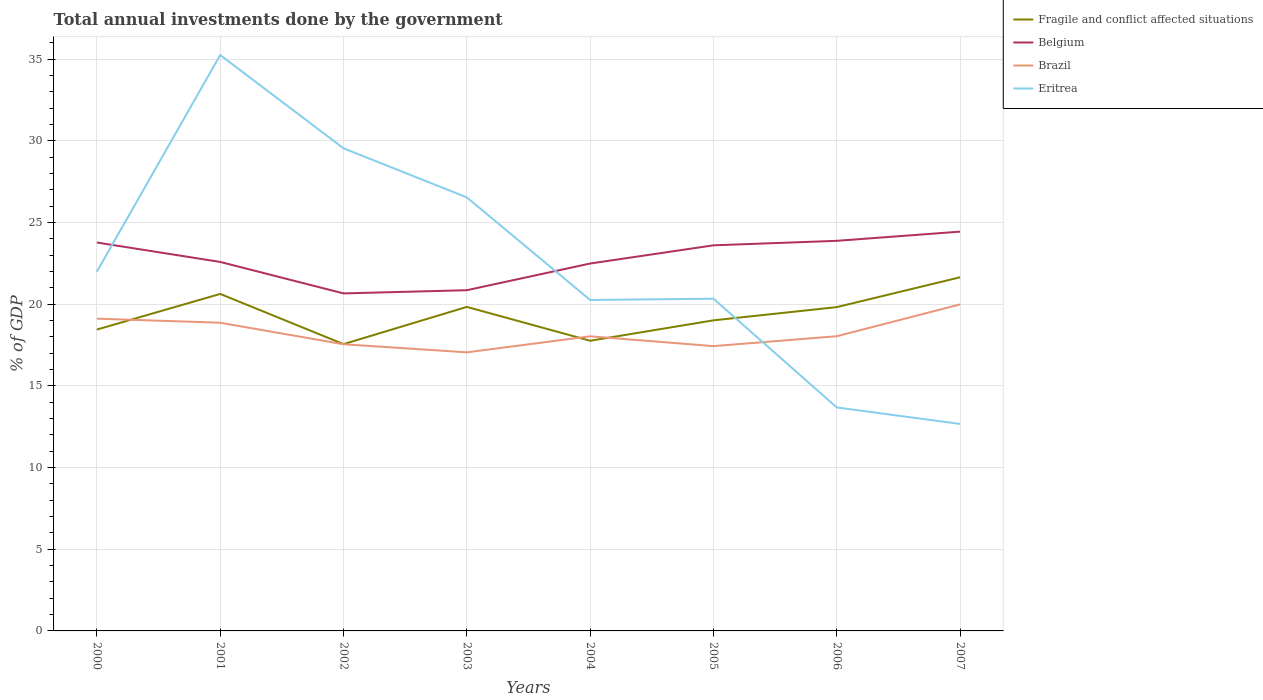Does the line corresponding to Fragile and conflict affected situations intersect with the line corresponding to Belgium?
Keep it short and to the point. No. Across all years, what is the maximum total annual investments done by the government in Fragile and conflict affected situations?
Keep it short and to the point. 17.56. In which year was the total annual investments done by the government in Fragile and conflict affected situations maximum?
Your answer should be very brief. 2002. What is the total total annual investments done by the government in Brazil in the graph?
Keep it short and to the point. -0.49. What is the difference between the highest and the second highest total annual investments done by the government in Belgium?
Offer a very short reply. 3.78. What is the difference between the highest and the lowest total annual investments done by the government in Belgium?
Give a very brief answer. 4. How many lines are there?
Your response must be concise. 4. How many years are there in the graph?
Give a very brief answer. 8. What is the difference between two consecutive major ticks on the Y-axis?
Your answer should be compact. 5. Does the graph contain any zero values?
Your answer should be compact. No. Does the graph contain grids?
Your answer should be compact. Yes. How are the legend labels stacked?
Your answer should be very brief. Vertical. What is the title of the graph?
Provide a succinct answer. Total annual investments done by the government. What is the label or title of the Y-axis?
Provide a succinct answer. % of GDP. What is the % of GDP in Fragile and conflict affected situations in 2000?
Your answer should be compact. 18.45. What is the % of GDP in Belgium in 2000?
Your answer should be very brief. 23.78. What is the % of GDP of Brazil in 2000?
Make the answer very short. 19.12. What is the % of GDP in Eritrea in 2000?
Your response must be concise. 22. What is the % of GDP of Fragile and conflict affected situations in 2001?
Offer a very short reply. 20.63. What is the % of GDP of Belgium in 2001?
Ensure brevity in your answer.  22.59. What is the % of GDP of Brazil in 2001?
Provide a short and direct response. 18.87. What is the % of GDP in Eritrea in 2001?
Offer a terse response. 35.26. What is the % of GDP of Fragile and conflict affected situations in 2002?
Make the answer very short. 17.56. What is the % of GDP of Belgium in 2002?
Give a very brief answer. 20.66. What is the % of GDP of Brazil in 2002?
Offer a terse response. 17.55. What is the % of GDP in Eritrea in 2002?
Provide a short and direct response. 29.55. What is the % of GDP of Fragile and conflict affected situations in 2003?
Your answer should be very brief. 19.84. What is the % of GDP in Belgium in 2003?
Offer a terse response. 20.86. What is the % of GDP of Brazil in 2003?
Your answer should be compact. 17.06. What is the % of GDP of Eritrea in 2003?
Offer a very short reply. 26.54. What is the % of GDP in Fragile and conflict affected situations in 2004?
Give a very brief answer. 17.77. What is the % of GDP of Belgium in 2004?
Your response must be concise. 22.49. What is the % of GDP of Brazil in 2004?
Make the answer very short. 18.04. What is the % of GDP of Eritrea in 2004?
Give a very brief answer. 20.26. What is the % of GDP in Fragile and conflict affected situations in 2005?
Your answer should be compact. 19.02. What is the % of GDP in Belgium in 2005?
Ensure brevity in your answer.  23.61. What is the % of GDP of Brazil in 2005?
Provide a short and direct response. 17.44. What is the % of GDP of Eritrea in 2005?
Your response must be concise. 20.34. What is the % of GDP in Fragile and conflict affected situations in 2006?
Your answer should be very brief. 19.83. What is the % of GDP of Belgium in 2006?
Offer a very short reply. 23.88. What is the % of GDP in Brazil in 2006?
Make the answer very short. 18.04. What is the % of GDP in Eritrea in 2006?
Ensure brevity in your answer.  13.68. What is the % of GDP of Fragile and conflict affected situations in 2007?
Make the answer very short. 21.65. What is the % of GDP in Belgium in 2007?
Give a very brief answer. 24.45. What is the % of GDP in Brazil in 2007?
Your answer should be very brief. 19.99. What is the % of GDP of Eritrea in 2007?
Your response must be concise. 12.67. Across all years, what is the maximum % of GDP of Fragile and conflict affected situations?
Offer a terse response. 21.65. Across all years, what is the maximum % of GDP in Belgium?
Provide a short and direct response. 24.45. Across all years, what is the maximum % of GDP of Brazil?
Keep it short and to the point. 19.99. Across all years, what is the maximum % of GDP in Eritrea?
Your response must be concise. 35.26. Across all years, what is the minimum % of GDP in Fragile and conflict affected situations?
Give a very brief answer. 17.56. Across all years, what is the minimum % of GDP in Belgium?
Give a very brief answer. 20.66. Across all years, what is the minimum % of GDP in Brazil?
Offer a very short reply. 17.06. Across all years, what is the minimum % of GDP in Eritrea?
Your response must be concise. 12.67. What is the total % of GDP in Fragile and conflict affected situations in the graph?
Give a very brief answer. 154.74. What is the total % of GDP in Belgium in the graph?
Keep it short and to the point. 182.33. What is the total % of GDP of Brazil in the graph?
Provide a succinct answer. 146.11. What is the total % of GDP of Eritrea in the graph?
Your response must be concise. 180.31. What is the difference between the % of GDP in Fragile and conflict affected situations in 2000 and that in 2001?
Offer a very short reply. -2.18. What is the difference between the % of GDP of Belgium in 2000 and that in 2001?
Ensure brevity in your answer.  1.19. What is the difference between the % of GDP of Brazil in 2000 and that in 2001?
Keep it short and to the point. 0.25. What is the difference between the % of GDP in Eritrea in 2000 and that in 2001?
Keep it short and to the point. -13.26. What is the difference between the % of GDP in Fragile and conflict affected situations in 2000 and that in 2002?
Offer a very short reply. 0.89. What is the difference between the % of GDP in Belgium in 2000 and that in 2002?
Your answer should be very brief. 3.12. What is the difference between the % of GDP of Brazil in 2000 and that in 2002?
Your response must be concise. 1.57. What is the difference between the % of GDP in Eritrea in 2000 and that in 2002?
Provide a succinct answer. -7.55. What is the difference between the % of GDP of Fragile and conflict affected situations in 2000 and that in 2003?
Your response must be concise. -1.39. What is the difference between the % of GDP of Belgium in 2000 and that in 2003?
Offer a terse response. 2.92. What is the difference between the % of GDP in Brazil in 2000 and that in 2003?
Make the answer very short. 2.06. What is the difference between the % of GDP of Eritrea in 2000 and that in 2003?
Give a very brief answer. -4.55. What is the difference between the % of GDP in Fragile and conflict affected situations in 2000 and that in 2004?
Keep it short and to the point. 0.68. What is the difference between the % of GDP of Belgium in 2000 and that in 2004?
Offer a terse response. 1.29. What is the difference between the % of GDP in Brazil in 2000 and that in 2004?
Provide a short and direct response. 1.08. What is the difference between the % of GDP of Eritrea in 2000 and that in 2004?
Ensure brevity in your answer.  1.73. What is the difference between the % of GDP of Fragile and conflict affected situations in 2000 and that in 2005?
Your answer should be compact. -0.57. What is the difference between the % of GDP of Belgium in 2000 and that in 2005?
Provide a succinct answer. 0.17. What is the difference between the % of GDP of Brazil in 2000 and that in 2005?
Provide a short and direct response. 1.68. What is the difference between the % of GDP in Eritrea in 2000 and that in 2005?
Offer a terse response. 1.66. What is the difference between the % of GDP in Fragile and conflict affected situations in 2000 and that in 2006?
Ensure brevity in your answer.  -1.38. What is the difference between the % of GDP of Belgium in 2000 and that in 2006?
Offer a very short reply. -0.1. What is the difference between the % of GDP in Brazil in 2000 and that in 2006?
Give a very brief answer. 1.08. What is the difference between the % of GDP in Eritrea in 2000 and that in 2006?
Offer a very short reply. 8.32. What is the difference between the % of GDP of Fragile and conflict affected situations in 2000 and that in 2007?
Offer a terse response. -3.2. What is the difference between the % of GDP of Belgium in 2000 and that in 2007?
Give a very brief answer. -0.67. What is the difference between the % of GDP in Brazil in 2000 and that in 2007?
Your response must be concise. -0.87. What is the difference between the % of GDP of Eritrea in 2000 and that in 2007?
Offer a terse response. 9.32. What is the difference between the % of GDP in Fragile and conflict affected situations in 2001 and that in 2002?
Your answer should be compact. 3.07. What is the difference between the % of GDP in Belgium in 2001 and that in 2002?
Give a very brief answer. 1.93. What is the difference between the % of GDP in Brazil in 2001 and that in 2002?
Make the answer very short. 1.32. What is the difference between the % of GDP of Eritrea in 2001 and that in 2002?
Ensure brevity in your answer.  5.71. What is the difference between the % of GDP in Fragile and conflict affected situations in 2001 and that in 2003?
Give a very brief answer. 0.79. What is the difference between the % of GDP of Belgium in 2001 and that in 2003?
Keep it short and to the point. 1.73. What is the difference between the % of GDP in Brazil in 2001 and that in 2003?
Your response must be concise. 1.81. What is the difference between the % of GDP in Eritrea in 2001 and that in 2003?
Make the answer very short. 8.72. What is the difference between the % of GDP of Fragile and conflict affected situations in 2001 and that in 2004?
Ensure brevity in your answer.  2.87. What is the difference between the % of GDP in Belgium in 2001 and that in 2004?
Provide a succinct answer. 0.1. What is the difference between the % of GDP in Brazil in 2001 and that in 2004?
Make the answer very short. 0.83. What is the difference between the % of GDP in Eritrea in 2001 and that in 2004?
Ensure brevity in your answer.  15. What is the difference between the % of GDP of Fragile and conflict affected situations in 2001 and that in 2005?
Your answer should be compact. 1.62. What is the difference between the % of GDP in Belgium in 2001 and that in 2005?
Keep it short and to the point. -1.02. What is the difference between the % of GDP of Brazil in 2001 and that in 2005?
Keep it short and to the point. 1.43. What is the difference between the % of GDP in Eritrea in 2001 and that in 2005?
Provide a succinct answer. 14.92. What is the difference between the % of GDP of Fragile and conflict affected situations in 2001 and that in 2006?
Your answer should be very brief. 0.81. What is the difference between the % of GDP of Belgium in 2001 and that in 2006?
Make the answer very short. -1.29. What is the difference between the % of GDP in Brazil in 2001 and that in 2006?
Your response must be concise. 0.83. What is the difference between the % of GDP in Eritrea in 2001 and that in 2006?
Provide a short and direct response. 21.58. What is the difference between the % of GDP in Fragile and conflict affected situations in 2001 and that in 2007?
Provide a short and direct response. -1.02. What is the difference between the % of GDP in Belgium in 2001 and that in 2007?
Provide a succinct answer. -1.86. What is the difference between the % of GDP of Brazil in 2001 and that in 2007?
Provide a short and direct response. -1.12. What is the difference between the % of GDP of Eritrea in 2001 and that in 2007?
Your answer should be very brief. 22.59. What is the difference between the % of GDP of Fragile and conflict affected situations in 2002 and that in 2003?
Your answer should be compact. -2.28. What is the difference between the % of GDP in Belgium in 2002 and that in 2003?
Provide a succinct answer. -0.2. What is the difference between the % of GDP in Brazil in 2002 and that in 2003?
Make the answer very short. 0.49. What is the difference between the % of GDP in Eritrea in 2002 and that in 2003?
Offer a terse response. 3. What is the difference between the % of GDP of Fragile and conflict affected situations in 2002 and that in 2004?
Your answer should be very brief. -0.21. What is the difference between the % of GDP in Belgium in 2002 and that in 2004?
Your response must be concise. -1.83. What is the difference between the % of GDP in Brazil in 2002 and that in 2004?
Offer a very short reply. -0.49. What is the difference between the % of GDP of Eritrea in 2002 and that in 2004?
Offer a very short reply. 9.29. What is the difference between the % of GDP in Fragile and conflict affected situations in 2002 and that in 2005?
Keep it short and to the point. -1.46. What is the difference between the % of GDP of Belgium in 2002 and that in 2005?
Give a very brief answer. -2.94. What is the difference between the % of GDP in Brazil in 2002 and that in 2005?
Provide a short and direct response. 0.11. What is the difference between the % of GDP of Eritrea in 2002 and that in 2005?
Make the answer very short. 9.21. What is the difference between the % of GDP of Fragile and conflict affected situations in 2002 and that in 2006?
Offer a terse response. -2.27. What is the difference between the % of GDP of Belgium in 2002 and that in 2006?
Your response must be concise. -3.22. What is the difference between the % of GDP of Brazil in 2002 and that in 2006?
Your response must be concise. -0.49. What is the difference between the % of GDP of Eritrea in 2002 and that in 2006?
Offer a terse response. 15.87. What is the difference between the % of GDP of Fragile and conflict affected situations in 2002 and that in 2007?
Your answer should be compact. -4.09. What is the difference between the % of GDP of Belgium in 2002 and that in 2007?
Provide a succinct answer. -3.78. What is the difference between the % of GDP in Brazil in 2002 and that in 2007?
Offer a very short reply. -2.44. What is the difference between the % of GDP in Eritrea in 2002 and that in 2007?
Provide a succinct answer. 16.88. What is the difference between the % of GDP of Fragile and conflict affected situations in 2003 and that in 2004?
Your answer should be very brief. 2.07. What is the difference between the % of GDP of Belgium in 2003 and that in 2004?
Ensure brevity in your answer.  -1.63. What is the difference between the % of GDP of Brazil in 2003 and that in 2004?
Ensure brevity in your answer.  -0.98. What is the difference between the % of GDP of Eritrea in 2003 and that in 2004?
Make the answer very short. 6.28. What is the difference between the % of GDP in Fragile and conflict affected situations in 2003 and that in 2005?
Give a very brief answer. 0.82. What is the difference between the % of GDP of Belgium in 2003 and that in 2005?
Your response must be concise. -2.75. What is the difference between the % of GDP of Brazil in 2003 and that in 2005?
Offer a very short reply. -0.38. What is the difference between the % of GDP of Eritrea in 2003 and that in 2005?
Provide a short and direct response. 6.2. What is the difference between the % of GDP of Fragile and conflict affected situations in 2003 and that in 2006?
Provide a succinct answer. 0.01. What is the difference between the % of GDP in Belgium in 2003 and that in 2006?
Your answer should be compact. -3.02. What is the difference between the % of GDP in Brazil in 2003 and that in 2006?
Offer a terse response. -0.99. What is the difference between the % of GDP in Eritrea in 2003 and that in 2006?
Offer a terse response. 12.86. What is the difference between the % of GDP in Fragile and conflict affected situations in 2003 and that in 2007?
Your answer should be compact. -1.81. What is the difference between the % of GDP in Belgium in 2003 and that in 2007?
Offer a terse response. -3.59. What is the difference between the % of GDP of Brazil in 2003 and that in 2007?
Make the answer very short. -2.93. What is the difference between the % of GDP of Eritrea in 2003 and that in 2007?
Provide a succinct answer. 13.87. What is the difference between the % of GDP in Fragile and conflict affected situations in 2004 and that in 2005?
Ensure brevity in your answer.  -1.25. What is the difference between the % of GDP in Belgium in 2004 and that in 2005?
Make the answer very short. -1.11. What is the difference between the % of GDP of Brazil in 2004 and that in 2005?
Keep it short and to the point. 0.6. What is the difference between the % of GDP in Eritrea in 2004 and that in 2005?
Keep it short and to the point. -0.08. What is the difference between the % of GDP in Fragile and conflict affected situations in 2004 and that in 2006?
Provide a succinct answer. -2.06. What is the difference between the % of GDP of Belgium in 2004 and that in 2006?
Your response must be concise. -1.39. What is the difference between the % of GDP of Brazil in 2004 and that in 2006?
Offer a very short reply. -0. What is the difference between the % of GDP in Eritrea in 2004 and that in 2006?
Make the answer very short. 6.58. What is the difference between the % of GDP in Fragile and conflict affected situations in 2004 and that in 2007?
Give a very brief answer. -3.89. What is the difference between the % of GDP of Belgium in 2004 and that in 2007?
Make the answer very short. -1.95. What is the difference between the % of GDP in Brazil in 2004 and that in 2007?
Provide a succinct answer. -1.95. What is the difference between the % of GDP of Eritrea in 2004 and that in 2007?
Offer a very short reply. 7.59. What is the difference between the % of GDP of Fragile and conflict affected situations in 2005 and that in 2006?
Make the answer very short. -0.81. What is the difference between the % of GDP in Belgium in 2005 and that in 2006?
Your answer should be very brief. -0.28. What is the difference between the % of GDP of Brazil in 2005 and that in 2006?
Keep it short and to the point. -0.61. What is the difference between the % of GDP of Eritrea in 2005 and that in 2006?
Offer a very short reply. 6.66. What is the difference between the % of GDP of Fragile and conflict affected situations in 2005 and that in 2007?
Provide a short and direct response. -2.64. What is the difference between the % of GDP in Belgium in 2005 and that in 2007?
Offer a very short reply. -0.84. What is the difference between the % of GDP in Brazil in 2005 and that in 2007?
Offer a very short reply. -2.55. What is the difference between the % of GDP in Eritrea in 2005 and that in 2007?
Your answer should be compact. 7.67. What is the difference between the % of GDP in Fragile and conflict affected situations in 2006 and that in 2007?
Your response must be concise. -1.83. What is the difference between the % of GDP of Belgium in 2006 and that in 2007?
Your response must be concise. -0.56. What is the difference between the % of GDP of Brazil in 2006 and that in 2007?
Give a very brief answer. -1.95. What is the difference between the % of GDP of Eritrea in 2006 and that in 2007?
Give a very brief answer. 1.01. What is the difference between the % of GDP in Fragile and conflict affected situations in 2000 and the % of GDP in Belgium in 2001?
Keep it short and to the point. -4.14. What is the difference between the % of GDP of Fragile and conflict affected situations in 2000 and the % of GDP of Brazil in 2001?
Ensure brevity in your answer.  -0.42. What is the difference between the % of GDP of Fragile and conflict affected situations in 2000 and the % of GDP of Eritrea in 2001?
Your response must be concise. -16.81. What is the difference between the % of GDP of Belgium in 2000 and the % of GDP of Brazil in 2001?
Offer a very short reply. 4.91. What is the difference between the % of GDP of Belgium in 2000 and the % of GDP of Eritrea in 2001?
Your response must be concise. -11.48. What is the difference between the % of GDP in Brazil in 2000 and the % of GDP in Eritrea in 2001?
Keep it short and to the point. -16.14. What is the difference between the % of GDP of Fragile and conflict affected situations in 2000 and the % of GDP of Belgium in 2002?
Your answer should be compact. -2.21. What is the difference between the % of GDP of Fragile and conflict affected situations in 2000 and the % of GDP of Brazil in 2002?
Your response must be concise. 0.9. What is the difference between the % of GDP in Fragile and conflict affected situations in 2000 and the % of GDP in Eritrea in 2002?
Your response must be concise. -11.1. What is the difference between the % of GDP in Belgium in 2000 and the % of GDP in Brazil in 2002?
Offer a terse response. 6.23. What is the difference between the % of GDP of Belgium in 2000 and the % of GDP of Eritrea in 2002?
Your answer should be very brief. -5.77. What is the difference between the % of GDP in Brazil in 2000 and the % of GDP in Eritrea in 2002?
Ensure brevity in your answer.  -10.43. What is the difference between the % of GDP of Fragile and conflict affected situations in 2000 and the % of GDP of Belgium in 2003?
Make the answer very short. -2.41. What is the difference between the % of GDP of Fragile and conflict affected situations in 2000 and the % of GDP of Brazil in 2003?
Your response must be concise. 1.39. What is the difference between the % of GDP of Fragile and conflict affected situations in 2000 and the % of GDP of Eritrea in 2003?
Give a very brief answer. -8.09. What is the difference between the % of GDP of Belgium in 2000 and the % of GDP of Brazil in 2003?
Give a very brief answer. 6.72. What is the difference between the % of GDP in Belgium in 2000 and the % of GDP in Eritrea in 2003?
Your answer should be very brief. -2.76. What is the difference between the % of GDP in Brazil in 2000 and the % of GDP in Eritrea in 2003?
Offer a very short reply. -7.42. What is the difference between the % of GDP in Fragile and conflict affected situations in 2000 and the % of GDP in Belgium in 2004?
Give a very brief answer. -4.04. What is the difference between the % of GDP in Fragile and conflict affected situations in 2000 and the % of GDP in Brazil in 2004?
Your answer should be compact. 0.41. What is the difference between the % of GDP of Fragile and conflict affected situations in 2000 and the % of GDP of Eritrea in 2004?
Give a very brief answer. -1.81. What is the difference between the % of GDP of Belgium in 2000 and the % of GDP of Brazil in 2004?
Provide a short and direct response. 5.74. What is the difference between the % of GDP in Belgium in 2000 and the % of GDP in Eritrea in 2004?
Your answer should be very brief. 3.52. What is the difference between the % of GDP in Brazil in 2000 and the % of GDP in Eritrea in 2004?
Give a very brief answer. -1.14. What is the difference between the % of GDP in Fragile and conflict affected situations in 2000 and the % of GDP in Belgium in 2005?
Provide a succinct answer. -5.16. What is the difference between the % of GDP in Fragile and conflict affected situations in 2000 and the % of GDP in Brazil in 2005?
Provide a short and direct response. 1.01. What is the difference between the % of GDP of Fragile and conflict affected situations in 2000 and the % of GDP of Eritrea in 2005?
Your response must be concise. -1.89. What is the difference between the % of GDP of Belgium in 2000 and the % of GDP of Brazil in 2005?
Your answer should be very brief. 6.34. What is the difference between the % of GDP of Belgium in 2000 and the % of GDP of Eritrea in 2005?
Ensure brevity in your answer.  3.44. What is the difference between the % of GDP of Brazil in 2000 and the % of GDP of Eritrea in 2005?
Make the answer very short. -1.22. What is the difference between the % of GDP in Fragile and conflict affected situations in 2000 and the % of GDP in Belgium in 2006?
Your answer should be compact. -5.43. What is the difference between the % of GDP of Fragile and conflict affected situations in 2000 and the % of GDP of Brazil in 2006?
Keep it short and to the point. 0.41. What is the difference between the % of GDP in Fragile and conflict affected situations in 2000 and the % of GDP in Eritrea in 2006?
Your answer should be compact. 4.77. What is the difference between the % of GDP of Belgium in 2000 and the % of GDP of Brazil in 2006?
Provide a succinct answer. 5.74. What is the difference between the % of GDP in Belgium in 2000 and the % of GDP in Eritrea in 2006?
Your answer should be very brief. 10.1. What is the difference between the % of GDP of Brazil in 2000 and the % of GDP of Eritrea in 2006?
Your answer should be compact. 5.44. What is the difference between the % of GDP in Fragile and conflict affected situations in 2000 and the % of GDP in Belgium in 2007?
Your answer should be very brief. -6. What is the difference between the % of GDP in Fragile and conflict affected situations in 2000 and the % of GDP in Brazil in 2007?
Provide a succinct answer. -1.54. What is the difference between the % of GDP in Fragile and conflict affected situations in 2000 and the % of GDP in Eritrea in 2007?
Your answer should be very brief. 5.78. What is the difference between the % of GDP of Belgium in 2000 and the % of GDP of Brazil in 2007?
Offer a very short reply. 3.79. What is the difference between the % of GDP in Belgium in 2000 and the % of GDP in Eritrea in 2007?
Provide a short and direct response. 11.11. What is the difference between the % of GDP in Brazil in 2000 and the % of GDP in Eritrea in 2007?
Offer a terse response. 6.45. What is the difference between the % of GDP in Fragile and conflict affected situations in 2001 and the % of GDP in Belgium in 2002?
Offer a very short reply. -0.03. What is the difference between the % of GDP in Fragile and conflict affected situations in 2001 and the % of GDP in Brazil in 2002?
Provide a succinct answer. 3.08. What is the difference between the % of GDP of Fragile and conflict affected situations in 2001 and the % of GDP of Eritrea in 2002?
Offer a terse response. -8.92. What is the difference between the % of GDP in Belgium in 2001 and the % of GDP in Brazil in 2002?
Your answer should be compact. 5.04. What is the difference between the % of GDP of Belgium in 2001 and the % of GDP of Eritrea in 2002?
Your response must be concise. -6.96. What is the difference between the % of GDP of Brazil in 2001 and the % of GDP of Eritrea in 2002?
Make the answer very short. -10.68. What is the difference between the % of GDP of Fragile and conflict affected situations in 2001 and the % of GDP of Belgium in 2003?
Your answer should be compact. -0.23. What is the difference between the % of GDP of Fragile and conflict affected situations in 2001 and the % of GDP of Brazil in 2003?
Your answer should be very brief. 3.58. What is the difference between the % of GDP of Fragile and conflict affected situations in 2001 and the % of GDP of Eritrea in 2003?
Offer a terse response. -5.91. What is the difference between the % of GDP in Belgium in 2001 and the % of GDP in Brazil in 2003?
Your answer should be very brief. 5.54. What is the difference between the % of GDP in Belgium in 2001 and the % of GDP in Eritrea in 2003?
Provide a short and direct response. -3.95. What is the difference between the % of GDP in Brazil in 2001 and the % of GDP in Eritrea in 2003?
Your response must be concise. -7.67. What is the difference between the % of GDP of Fragile and conflict affected situations in 2001 and the % of GDP of Belgium in 2004?
Offer a very short reply. -1.86. What is the difference between the % of GDP of Fragile and conflict affected situations in 2001 and the % of GDP of Brazil in 2004?
Offer a very short reply. 2.59. What is the difference between the % of GDP in Fragile and conflict affected situations in 2001 and the % of GDP in Eritrea in 2004?
Your answer should be compact. 0.37. What is the difference between the % of GDP of Belgium in 2001 and the % of GDP of Brazil in 2004?
Give a very brief answer. 4.55. What is the difference between the % of GDP of Belgium in 2001 and the % of GDP of Eritrea in 2004?
Your answer should be very brief. 2.33. What is the difference between the % of GDP of Brazil in 2001 and the % of GDP of Eritrea in 2004?
Your answer should be very brief. -1.39. What is the difference between the % of GDP in Fragile and conflict affected situations in 2001 and the % of GDP in Belgium in 2005?
Your answer should be very brief. -2.98. What is the difference between the % of GDP of Fragile and conflict affected situations in 2001 and the % of GDP of Brazil in 2005?
Make the answer very short. 3.2. What is the difference between the % of GDP of Fragile and conflict affected situations in 2001 and the % of GDP of Eritrea in 2005?
Your answer should be compact. 0.29. What is the difference between the % of GDP of Belgium in 2001 and the % of GDP of Brazil in 2005?
Provide a short and direct response. 5.16. What is the difference between the % of GDP in Belgium in 2001 and the % of GDP in Eritrea in 2005?
Offer a very short reply. 2.25. What is the difference between the % of GDP of Brazil in 2001 and the % of GDP of Eritrea in 2005?
Offer a terse response. -1.47. What is the difference between the % of GDP in Fragile and conflict affected situations in 2001 and the % of GDP in Belgium in 2006?
Ensure brevity in your answer.  -3.25. What is the difference between the % of GDP of Fragile and conflict affected situations in 2001 and the % of GDP of Brazil in 2006?
Your answer should be very brief. 2.59. What is the difference between the % of GDP in Fragile and conflict affected situations in 2001 and the % of GDP in Eritrea in 2006?
Your answer should be very brief. 6.95. What is the difference between the % of GDP of Belgium in 2001 and the % of GDP of Brazil in 2006?
Offer a terse response. 4.55. What is the difference between the % of GDP of Belgium in 2001 and the % of GDP of Eritrea in 2006?
Offer a very short reply. 8.91. What is the difference between the % of GDP in Brazil in 2001 and the % of GDP in Eritrea in 2006?
Keep it short and to the point. 5.19. What is the difference between the % of GDP of Fragile and conflict affected situations in 2001 and the % of GDP of Belgium in 2007?
Provide a succinct answer. -3.81. What is the difference between the % of GDP in Fragile and conflict affected situations in 2001 and the % of GDP in Brazil in 2007?
Keep it short and to the point. 0.64. What is the difference between the % of GDP in Fragile and conflict affected situations in 2001 and the % of GDP in Eritrea in 2007?
Your response must be concise. 7.96. What is the difference between the % of GDP of Belgium in 2001 and the % of GDP of Brazil in 2007?
Provide a succinct answer. 2.6. What is the difference between the % of GDP of Belgium in 2001 and the % of GDP of Eritrea in 2007?
Your response must be concise. 9.92. What is the difference between the % of GDP of Brazil in 2001 and the % of GDP of Eritrea in 2007?
Provide a succinct answer. 6.2. What is the difference between the % of GDP of Fragile and conflict affected situations in 2002 and the % of GDP of Belgium in 2003?
Your response must be concise. -3.3. What is the difference between the % of GDP in Fragile and conflict affected situations in 2002 and the % of GDP in Brazil in 2003?
Your answer should be compact. 0.5. What is the difference between the % of GDP in Fragile and conflict affected situations in 2002 and the % of GDP in Eritrea in 2003?
Ensure brevity in your answer.  -8.98. What is the difference between the % of GDP in Belgium in 2002 and the % of GDP in Brazil in 2003?
Provide a short and direct response. 3.61. What is the difference between the % of GDP in Belgium in 2002 and the % of GDP in Eritrea in 2003?
Ensure brevity in your answer.  -5.88. What is the difference between the % of GDP in Brazil in 2002 and the % of GDP in Eritrea in 2003?
Ensure brevity in your answer.  -8.99. What is the difference between the % of GDP of Fragile and conflict affected situations in 2002 and the % of GDP of Belgium in 2004?
Make the answer very short. -4.93. What is the difference between the % of GDP in Fragile and conflict affected situations in 2002 and the % of GDP in Brazil in 2004?
Offer a very short reply. -0.48. What is the difference between the % of GDP of Fragile and conflict affected situations in 2002 and the % of GDP of Eritrea in 2004?
Offer a very short reply. -2.7. What is the difference between the % of GDP in Belgium in 2002 and the % of GDP in Brazil in 2004?
Provide a succinct answer. 2.63. What is the difference between the % of GDP of Belgium in 2002 and the % of GDP of Eritrea in 2004?
Provide a succinct answer. 0.4. What is the difference between the % of GDP of Brazil in 2002 and the % of GDP of Eritrea in 2004?
Give a very brief answer. -2.71. What is the difference between the % of GDP of Fragile and conflict affected situations in 2002 and the % of GDP of Belgium in 2005?
Offer a very short reply. -6.05. What is the difference between the % of GDP in Fragile and conflict affected situations in 2002 and the % of GDP in Brazil in 2005?
Keep it short and to the point. 0.12. What is the difference between the % of GDP of Fragile and conflict affected situations in 2002 and the % of GDP of Eritrea in 2005?
Your answer should be very brief. -2.78. What is the difference between the % of GDP of Belgium in 2002 and the % of GDP of Brazil in 2005?
Ensure brevity in your answer.  3.23. What is the difference between the % of GDP of Belgium in 2002 and the % of GDP of Eritrea in 2005?
Your answer should be compact. 0.33. What is the difference between the % of GDP in Brazil in 2002 and the % of GDP in Eritrea in 2005?
Provide a succinct answer. -2.79. What is the difference between the % of GDP in Fragile and conflict affected situations in 2002 and the % of GDP in Belgium in 2006?
Give a very brief answer. -6.32. What is the difference between the % of GDP in Fragile and conflict affected situations in 2002 and the % of GDP in Brazil in 2006?
Your answer should be compact. -0.48. What is the difference between the % of GDP in Fragile and conflict affected situations in 2002 and the % of GDP in Eritrea in 2006?
Keep it short and to the point. 3.88. What is the difference between the % of GDP in Belgium in 2002 and the % of GDP in Brazil in 2006?
Your answer should be very brief. 2.62. What is the difference between the % of GDP of Belgium in 2002 and the % of GDP of Eritrea in 2006?
Make the answer very short. 6.98. What is the difference between the % of GDP in Brazil in 2002 and the % of GDP in Eritrea in 2006?
Your answer should be compact. 3.87. What is the difference between the % of GDP of Fragile and conflict affected situations in 2002 and the % of GDP of Belgium in 2007?
Offer a terse response. -6.89. What is the difference between the % of GDP in Fragile and conflict affected situations in 2002 and the % of GDP in Brazil in 2007?
Offer a very short reply. -2.43. What is the difference between the % of GDP in Fragile and conflict affected situations in 2002 and the % of GDP in Eritrea in 2007?
Offer a terse response. 4.89. What is the difference between the % of GDP in Belgium in 2002 and the % of GDP in Brazil in 2007?
Offer a very short reply. 0.67. What is the difference between the % of GDP of Belgium in 2002 and the % of GDP of Eritrea in 2007?
Provide a short and direct response. 7.99. What is the difference between the % of GDP of Brazil in 2002 and the % of GDP of Eritrea in 2007?
Offer a terse response. 4.88. What is the difference between the % of GDP of Fragile and conflict affected situations in 2003 and the % of GDP of Belgium in 2004?
Give a very brief answer. -2.66. What is the difference between the % of GDP of Fragile and conflict affected situations in 2003 and the % of GDP of Brazil in 2004?
Your answer should be very brief. 1.8. What is the difference between the % of GDP in Fragile and conflict affected situations in 2003 and the % of GDP in Eritrea in 2004?
Give a very brief answer. -0.42. What is the difference between the % of GDP in Belgium in 2003 and the % of GDP in Brazil in 2004?
Offer a terse response. 2.82. What is the difference between the % of GDP in Belgium in 2003 and the % of GDP in Eritrea in 2004?
Give a very brief answer. 0.6. What is the difference between the % of GDP of Brazil in 2003 and the % of GDP of Eritrea in 2004?
Give a very brief answer. -3.21. What is the difference between the % of GDP of Fragile and conflict affected situations in 2003 and the % of GDP of Belgium in 2005?
Give a very brief answer. -3.77. What is the difference between the % of GDP in Fragile and conflict affected situations in 2003 and the % of GDP in Brazil in 2005?
Your response must be concise. 2.4. What is the difference between the % of GDP of Fragile and conflict affected situations in 2003 and the % of GDP of Eritrea in 2005?
Offer a very short reply. -0.5. What is the difference between the % of GDP of Belgium in 2003 and the % of GDP of Brazil in 2005?
Your response must be concise. 3.42. What is the difference between the % of GDP in Belgium in 2003 and the % of GDP in Eritrea in 2005?
Your answer should be very brief. 0.52. What is the difference between the % of GDP of Brazil in 2003 and the % of GDP of Eritrea in 2005?
Offer a terse response. -3.28. What is the difference between the % of GDP of Fragile and conflict affected situations in 2003 and the % of GDP of Belgium in 2006?
Ensure brevity in your answer.  -4.05. What is the difference between the % of GDP in Fragile and conflict affected situations in 2003 and the % of GDP in Brazil in 2006?
Your answer should be compact. 1.79. What is the difference between the % of GDP of Fragile and conflict affected situations in 2003 and the % of GDP of Eritrea in 2006?
Offer a very short reply. 6.16. What is the difference between the % of GDP of Belgium in 2003 and the % of GDP of Brazil in 2006?
Offer a terse response. 2.82. What is the difference between the % of GDP of Belgium in 2003 and the % of GDP of Eritrea in 2006?
Offer a very short reply. 7.18. What is the difference between the % of GDP of Brazil in 2003 and the % of GDP of Eritrea in 2006?
Provide a succinct answer. 3.38. What is the difference between the % of GDP of Fragile and conflict affected situations in 2003 and the % of GDP of Belgium in 2007?
Provide a short and direct response. -4.61. What is the difference between the % of GDP in Fragile and conflict affected situations in 2003 and the % of GDP in Brazil in 2007?
Your answer should be very brief. -0.15. What is the difference between the % of GDP in Fragile and conflict affected situations in 2003 and the % of GDP in Eritrea in 2007?
Ensure brevity in your answer.  7.16. What is the difference between the % of GDP in Belgium in 2003 and the % of GDP in Brazil in 2007?
Offer a terse response. 0.87. What is the difference between the % of GDP in Belgium in 2003 and the % of GDP in Eritrea in 2007?
Offer a very short reply. 8.19. What is the difference between the % of GDP in Brazil in 2003 and the % of GDP in Eritrea in 2007?
Provide a succinct answer. 4.38. What is the difference between the % of GDP in Fragile and conflict affected situations in 2004 and the % of GDP in Belgium in 2005?
Your answer should be very brief. -5.84. What is the difference between the % of GDP of Fragile and conflict affected situations in 2004 and the % of GDP of Brazil in 2005?
Give a very brief answer. 0.33. What is the difference between the % of GDP in Fragile and conflict affected situations in 2004 and the % of GDP in Eritrea in 2005?
Offer a terse response. -2.57. What is the difference between the % of GDP of Belgium in 2004 and the % of GDP of Brazil in 2005?
Make the answer very short. 5.06. What is the difference between the % of GDP in Belgium in 2004 and the % of GDP in Eritrea in 2005?
Offer a terse response. 2.16. What is the difference between the % of GDP in Brazil in 2004 and the % of GDP in Eritrea in 2005?
Your answer should be compact. -2.3. What is the difference between the % of GDP in Fragile and conflict affected situations in 2004 and the % of GDP in Belgium in 2006?
Your answer should be compact. -6.12. What is the difference between the % of GDP of Fragile and conflict affected situations in 2004 and the % of GDP of Brazil in 2006?
Your answer should be very brief. -0.28. What is the difference between the % of GDP of Fragile and conflict affected situations in 2004 and the % of GDP of Eritrea in 2006?
Offer a terse response. 4.08. What is the difference between the % of GDP in Belgium in 2004 and the % of GDP in Brazil in 2006?
Ensure brevity in your answer.  4.45. What is the difference between the % of GDP of Belgium in 2004 and the % of GDP of Eritrea in 2006?
Ensure brevity in your answer.  8.81. What is the difference between the % of GDP of Brazil in 2004 and the % of GDP of Eritrea in 2006?
Ensure brevity in your answer.  4.36. What is the difference between the % of GDP of Fragile and conflict affected situations in 2004 and the % of GDP of Belgium in 2007?
Provide a short and direct response. -6.68. What is the difference between the % of GDP of Fragile and conflict affected situations in 2004 and the % of GDP of Brazil in 2007?
Offer a very short reply. -2.23. What is the difference between the % of GDP in Fragile and conflict affected situations in 2004 and the % of GDP in Eritrea in 2007?
Keep it short and to the point. 5.09. What is the difference between the % of GDP in Belgium in 2004 and the % of GDP in Brazil in 2007?
Ensure brevity in your answer.  2.5. What is the difference between the % of GDP in Belgium in 2004 and the % of GDP in Eritrea in 2007?
Your answer should be compact. 9.82. What is the difference between the % of GDP of Brazil in 2004 and the % of GDP of Eritrea in 2007?
Make the answer very short. 5.37. What is the difference between the % of GDP of Fragile and conflict affected situations in 2005 and the % of GDP of Belgium in 2006?
Make the answer very short. -4.87. What is the difference between the % of GDP in Fragile and conflict affected situations in 2005 and the % of GDP in Brazil in 2006?
Offer a terse response. 0.97. What is the difference between the % of GDP in Fragile and conflict affected situations in 2005 and the % of GDP in Eritrea in 2006?
Make the answer very short. 5.33. What is the difference between the % of GDP of Belgium in 2005 and the % of GDP of Brazil in 2006?
Give a very brief answer. 5.57. What is the difference between the % of GDP of Belgium in 2005 and the % of GDP of Eritrea in 2006?
Ensure brevity in your answer.  9.93. What is the difference between the % of GDP of Brazil in 2005 and the % of GDP of Eritrea in 2006?
Your answer should be very brief. 3.76. What is the difference between the % of GDP of Fragile and conflict affected situations in 2005 and the % of GDP of Belgium in 2007?
Offer a terse response. -5.43. What is the difference between the % of GDP in Fragile and conflict affected situations in 2005 and the % of GDP in Brazil in 2007?
Your answer should be very brief. -0.98. What is the difference between the % of GDP in Fragile and conflict affected situations in 2005 and the % of GDP in Eritrea in 2007?
Your answer should be very brief. 6.34. What is the difference between the % of GDP in Belgium in 2005 and the % of GDP in Brazil in 2007?
Make the answer very short. 3.62. What is the difference between the % of GDP in Belgium in 2005 and the % of GDP in Eritrea in 2007?
Your answer should be compact. 10.94. What is the difference between the % of GDP of Brazil in 2005 and the % of GDP of Eritrea in 2007?
Give a very brief answer. 4.76. What is the difference between the % of GDP in Fragile and conflict affected situations in 2006 and the % of GDP in Belgium in 2007?
Give a very brief answer. -4.62. What is the difference between the % of GDP in Fragile and conflict affected situations in 2006 and the % of GDP in Brazil in 2007?
Your answer should be very brief. -0.17. What is the difference between the % of GDP in Fragile and conflict affected situations in 2006 and the % of GDP in Eritrea in 2007?
Give a very brief answer. 7.15. What is the difference between the % of GDP in Belgium in 2006 and the % of GDP in Brazil in 2007?
Make the answer very short. 3.89. What is the difference between the % of GDP of Belgium in 2006 and the % of GDP of Eritrea in 2007?
Ensure brevity in your answer.  11.21. What is the difference between the % of GDP of Brazil in 2006 and the % of GDP of Eritrea in 2007?
Ensure brevity in your answer.  5.37. What is the average % of GDP in Fragile and conflict affected situations per year?
Your answer should be very brief. 19.34. What is the average % of GDP in Belgium per year?
Make the answer very short. 22.79. What is the average % of GDP in Brazil per year?
Make the answer very short. 18.26. What is the average % of GDP in Eritrea per year?
Ensure brevity in your answer.  22.54. In the year 2000, what is the difference between the % of GDP in Fragile and conflict affected situations and % of GDP in Belgium?
Your response must be concise. -5.33. In the year 2000, what is the difference between the % of GDP of Fragile and conflict affected situations and % of GDP of Brazil?
Give a very brief answer. -0.67. In the year 2000, what is the difference between the % of GDP of Fragile and conflict affected situations and % of GDP of Eritrea?
Keep it short and to the point. -3.55. In the year 2000, what is the difference between the % of GDP in Belgium and % of GDP in Brazil?
Make the answer very short. 4.66. In the year 2000, what is the difference between the % of GDP of Belgium and % of GDP of Eritrea?
Make the answer very short. 1.79. In the year 2000, what is the difference between the % of GDP in Brazil and % of GDP in Eritrea?
Make the answer very short. -2.88. In the year 2001, what is the difference between the % of GDP in Fragile and conflict affected situations and % of GDP in Belgium?
Provide a short and direct response. -1.96. In the year 2001, what is the difference between the % of GDP of Fragile and conflict affected situations and % of GDP of Brazil?
Your answer should be compact. 1.76. In the year 2001, what is the difference between the % of GDP in Fragile and conflict affected situations and % of GDP in Eritrea?
Give a very brief answer. -14.63. In the year 2001, what is the difference between the % of GDP of Belgium and % of GDP of Brazil?
Make the answer very short. 3.72. In the year 2001, what is the difference between the % of GDP of Belgium and % of GDP of Eritrea?
Ensure brevity in your answer.  -12.67. In the year 2001, what is the difference between the % of GDP of Brazil and % of GDP of Eritrea?
Your answer should be compact. -16.39. In the year 2002, what is the difference between the % of GDP of Fragile and conflict affected situations and % of GDP of Belgium?
Your answer should be very brief. -3.1. In the year 2002, what is the difference between the % of GDP in Fragile and conflict affected situations and % of GDP in Brazil?
Make the answer very short. 0.01. In the year 2002, what is the difference between the % of GDP of Fragile and conflict affected situations and % of GDP of Eritrea?
Offer a terse response. -11.99. In the year 2002, what is the difference between the % of GDP of Belgium and % of GDP of Brazil?
Offer a terse response. 3.11. In the year 2002, what is the difference between the % of GDP in Belgium and % of GDP in Eritrea?
Provide a short and direct response. -8.88. In the year 2002, what is the difference between the % of GDP in Brazil and % of GDP in Eritrea?
Your answer should be compact. -12. In the year 2003, what is the difference between the % of GDP of Fragile and conflict affected situations and % of GDP of Belgium?
Your answer should be compact. -1.02. In the year 2003, what is the difference between the % of GDP in Fragile and conflict affected situations and % of GDP in Brazil?
Your answer should be very brief. 2.78. In the year 2003, what is the difference between the % of GDP in Fragile and conflict affected situations and % of GDP in Eritrea?
Offer a terse response. -6.71. In the year 2003, what is the difference between the % of GDP of Belgium and % of GDP of Brazil?
Give a very brief answer. 3.8. In the year 2003, what is the difference between the % of GDP in Belgium and % of GDP in Eritrea?
Your response must be concise. -5.68. In the year 2003, what is the difference between the % of GDP in Brazil and % of GDP in Eritrea?
Ensure brevity in your answer.  -9.49. In the year 2004, what is the difference between the % of GDP of Fragile and conflict affected situations and % of GDP of Belgium?
Your answer should be compact. -4.73. In the year 2004, what is the difference between the % of GDP of Fragile and conflict affected situations and % of GDP of Brazil?
Offer a terse response. -0.27. In the year 2004, what is the difference between the % of GDP of Fragile and conflict affected situations and % of GDP of Eritrea?
Offer a terse response. -2.5. In the year 2004, what is the difference between the % of GDP of Belgium and % of GDP of Brazil?
Your response must be concise. 4.46. In the year 2004, what is the difference between the % of GDP in Belgium and % of GDP in Eritrea?
Give a very brief answer. 2.23. In the year 2004, what is the difference between the % of GDP of Brazil and % of GDP of Eritrea?
Give a very brief answer. -2.22. In the year 2005, what is the difference between the % of GDP of Fragile and conflict affected situations and % of GDP of Belgium?
Keep it short and to the point. -4.59. In the year 2005, what is the difference between the % of GDP in Fragile and conflict affected situations and % of GDP in Brazil?
Your answer should be compact. 1.58. In the year 2005, what is the difference between the % of GDP of Fragile and conflict affected situations and % of GDP of Eritrea?
Your answer should be very brief. -1.32. In the year 2005, what is the difference between the % of GDP in Belgium and % of GDP in Brazil?
Make the answer very short. 6.17. In the year 2005, what is the difference between the % of GDP in Belgium and % of GDP in Eritrea?
Your answer should be very brief. 3.27. In the year 2005, what is the difference between the % of GDP of Brazil and % of GDP of Eritrea?
Provide a succinct answer. -2.9. In the year 2006, what is the difference between the % of GDP in Fragile and conflict affected situations and % of GDP in Belgium?
Provide a short and direct response. -4.06. In the year 2006, what is the difference between the % of GDP in Fragile and conflict affected situations and % of GDP in Brazil?
Your answer should be very brief. 1.78. In the year 2006, what is the difference between the % of GDP of Fragile and conflict affected situations and % of GDP of Eritrea?
Your answer should be compact. 6.14. In the year 2006, what is the difference between the % of GDP in Belgium and % of GDP in Brazil?
Provide a short and direct response. 5.84. In the year 2006, what is the difference between the % of GDP in Belgium and % of GDP in Eritrea?
Your answer should be compact. 10.2. In the year 2006, what is the difference between the % of GDP in Brazil and % of GDP in Eritrea?
Offer a terse response. 4.36. In the year 2007, what is the difference between the % of GDP in Fragile and conflict affected situations and % of GDP in Belgium?
Your answer should be compact. -2.79. In the year 2007, what is the difference between the % of GDP of Fragile and conflict affected situations and % of GDP of Brazil?
Your response must be concise. 1.66. In the year 2007, what is the difference between the % of GDP of Fragile and conflict affected situations and % of GDP of Eritrea?
Provide a short and direct response. 8.98. In the year 2007, what is the difference between the % of GDP in Belgium and % of GDP in Brazil?
Provide a short and direct response. 4.46. In the year 2007, what is the difference between the % of GDP of Belgium and % of GDP of Eritrea?
Make the answer very short. 11.77. In the year 2007, what is the difference between the % of GDP of Brazil and % of GDP of Eritrea?
Your response must be concise. 7.32. What is the ratio of the % of GDP in Fragile and conflict affected situations in 2000 to that in 2001?
Keep it short and to the point. 0.89. What is the ratio of the % of GDP in Belgium in 2000 to that in 2001?
Ensure brevity in your answer.  1.05. What is the ratio of the % of GDP in Brazil in 2000 to that in 2001?
Offer a very short reply. 1.01. What is the ratio of the % of GDP in Eritrea in 2000 to that in 2001?
Give a very brief answer. 0.62. What is the ratio of the % of GDP of Fragile and conflict affected situations in 2000 to that in 2002?
Give a very brief answer. 1.05. What is the ratio of the % of GDP in Belgium in 2000 to that in 2002?
Make the answer very short. 1.15. What is the ratio of the % of GDP of Brazil in 2000 to that in 2002?
Ensure brevity in your answer.  1.09. What is the ratio of the % of GDP in Eritrea in 2000 to that in 2002?
Your answer should be compact. 0.74. What is the ratio of the % of GDP in Fragile and conflict affected situations in 2000 to that in 2003?
Make the answer very short. 0.93. What is the ratio of the % of GDP of Belgium in 2000 to that in 2003?
Offer a terse response. 1.14. What is the ratio of the % of GDP of Brazil in 2000 to that in 2003?
Provide a succinct answer. 1.12. What is the ratio of the % of GDP of Eritrea in 2000 to that in 2003?
Offer a very short reply. 0.83. What is the ratio of the % of GDP of Fragile and conflict affected situations in 2000 to that in 2004?
Your answer should be compact. 1.04. What is the ratio of the % of GDP of Belgium in 2000 to that in 2004?
Offer a very short reply. 1.06. What is the ratio of the % of GDP in Brazil in 2000 to that in 2004?
Ensure brevity in your answer.  1.06. What is the ratio of the % of GDP in Eritrea in 2000 to that in 2004?
Provide a short and direct response. 1.09. What is the ratio of the % of GDP of Fragile and conflict affected situations in 2000 to that in 2005?
Give a very brief answer. 0.97. What is the ratio of the % of GDP of Belgium in 2000 to that in 2005?
Your answer should be compact. 1.01. What is the ratio of the % of GDP in Brazil in 2000 to that in 2005?
Make the answer very short. 1.1. What is the ratio of the % of GDP of Eritrea in 2000 to that in 2005?
Give a very brief answer. 1.08. What is the ratio of the % of GDP in Fragile and conflict affected situations in 2000 to that in 2006?
Provide a short and direct response. 0.93. What is the ratio of the % of GDP in Belgium in 2000 to that in 2006?
Offer a very short reply. 1. What is the ratio of the % of GDP of Brazil in 2000 to that in 2006?
Your answer should be very brief. 1.06. What is the ratio of the % of GDP in Eritrea in 2000 to that in 2006?
Your answer should be very brief. 1.61. What is the ratio of the % of GDP in Fragile and conflict affected situations in 2000 to that in 2007?
Give a very brief answer. 0.85. What is the ratio of the % of GDP of Belgium in 2000 to that in 2007?
Offer a very short reply. 0.97. What is the ratio of the % of GDP in Brazil in 2000 to that in 2007?
Make the answer very short. 0.96. What is the ratio of the % of GDP in Eritrea in 2000 to that in 2007?
Offer a very short reply. 1.74. What is the ratio of the % of GDP of Fragile and conflict affected situations in 2001 to that in 2002?
Keep it short and to the point. 1.18. What is the ratio of the % of GDP of Belgium in 2001 to that in 2002?
Offer a terse response. 1.09. What is the ratio of the % of GDP in Brazil in 2001 to that in 2002?
Your answer should be compact. 1.08. What is the ratio of the % of GDP of Eritrea in 2001 to that in 2002?
Offer a terse response. 1.19. What is the ratio of the % of GDP in Fragile and conflict affected situations in 2001 to that in 2003?
Provide a short and direct response. 1.04. What is the ratio of the % of GDP in Belgium in 2001 to that in 2003?
Provide a succinct answer. 1.08. What is the ratio of the % of GDP of Brazil in 2001 to that in 2003?
Your response must be concise. 1.11. What is the ratio of the % of GDP of Eritrea in 2001 to that in 2003?
Give a very brief answer. 1.33. What is the ratio of the % of GDP in Fragile and conflict affected situations in 2001 to that in 2004?
Provide a succinct answer. 1.16. What is the ratio of the % of GDP in Brazil in 2001 to that in 2004?
Give a very brief answer. 1.05. What is the ratio of the % of GDP in Eritrea in 2001 to that in 2004?
Offer a terse response. 1.74. What is the ratio of the % of GDP in Fragile and conflict affected situations in 2001 to that in 2005?
Make the answer very short. 1.08. What is the ratio of the % of GDP in Belgium in 2001 to that in 2005?
Make the answer very short. 0.96. What is the ratio of the % of GDP of Brazil in 2001 to that in 2005?
Your answer should be compact. 1.08. What is the ratio of the % of GDP in Eritrea in 2001 to that in 2005?
Your answer should be compact. 1.73. What is the ratio of the % of GDP in Fragile and conflict affected situations in 2001 to that in 2006?
Your answer should be very brief. 1.04. What is the ratio of the % of GDP of Belgium in 2001 to that in 2006?
Your response must be concise. 0.95. What is the ratio of the % of GDP of Brazil in 2001 to that in 2006?
Your answer should be very brief. 1.05. What is the ratio of the % of GDP of Eritrea in 2001 to that in 2006?
Offer a very short reply. 2.58. What is the ratio of the % of GDP in Fragile and conflict affected situations in 2001 to that in 2007?
Ensure brevity in your answer.  0.95. What is the ratio of the % of GDP of Belgium in 2001 to that in 2007?
Ensure brevity in your answer.  0.92. What is the ratio of the % of GDP of Brazil in 2001 to that in 2007?
Give a very brief answer. 0.94. What is the ratio of the % of GDP in Eritrea in 2001 to that in 2007?
Offer a very short reply. 2.78. What is the ratio of the % of GDP in Fragile and conflict affected situations in 2002 to that in 2003?
Ensure brevity in your answer.  0.89. What is the ratio of the % of GDP of Belgium in 2002 to that in 2003?
Your answer should be very brief. 0.99. What is the ratio of the % of GDP of Brazil in 2002 to that in 2003?
Provide a succinct answer. 1.03. What is the ratio of the % of GDP in Eritrea in 2002 to that in 2003?
Keep it short and to the point. 1.11. What is the ratio of the % of GDP of Fragile and conflict affected situations in 2002 to that in 2004?
Ensure brevity in your answer.  0.99. What is the ratio of the % of GDP in Belgium in 2002 to that in 2004?
Your answer should be very brief. 0.92. What is the ratio of the % of GDP of Brazil in 2002 to that in 2004?
Ensure brevity in your answer.  0.97. What is the ratio of the % of GDP in Eritrea in 2002 to that in 2004?
Provide a succinct answer. 1.46. What is the ratio of the % of GDP of Fragile and conflict affected situations in 2002 to that in 2005?
Your answer should be very brief. 0.92. What is the ratio of the % of GDP in Belgium in 2002 to that in 2005?
Offer a terse response. 0.88. What is the ratio of the % of GDP in Brazil in 2002 to that in 2005?
Your answer should be compact. 1.01. What is the ratio of the % of GDP in Eritrea in 2002 to that in 2005?
Provide a short and direct response. 1.45. What is the ratio of the % of GDP in Fragile and conflict affected situations in 2002 to that in 2006?
Ensure brevity in your answer.  0.89. What is the ratio of the % of GDP in Belgium in 2002 to that in 2006?
Give a very brief answer. 0.87. What is the ratio of the % of GDP in Brazil in 2002 to that in 2006?
Provide a short and direct response. 0.97. What is the ratio of the % of GDP of Eritrea in 2002 to that in 2006?
Offer a very short reply. 2.16. What is the ratio of the % of GDP in Fragile and conflict affected situations in 2002 to that in 2007?
Your answer should be compact. 0.81. What is the ratio of the % of GDP of Belgium in 2002 to that in 2007?
Your answer should be very brief. 0.85. What is the ratio of the % of GDP in Brazil in 2002 to that in 2007?
Offer a very short reply. 0.88. What is the ratio of the % of GDP in Eritrea in 2002 to that in 2007?
Give a very brief answer. 2.33. What is the ratio of the % of GDP of Fragile and conflict affected situations in 2003 to that in 2004?
Provide a succinct answer. 1.12. What is the ratio of the % of GDP in Belgium in 2003 to that in 2004?
Your answer should be compact. 0.93. What is the ratio of the % of GDP of Brazil in 2003 to that in 2004?
Your answer should be very brief. 0.95. What is the ratio of the % of GDP in Eritrea in 2003 to that in 2004?
Provide a succinct answer. 1.31. What is the ratio of the % of GDP in Fragile and conflict affected situations in 2003 to that in 2005?
Your response must be concise. 1.04. What is the ratio of the % of GDP in Belgium in 2003 to that in 2005?
Ensure brevity in your answer.  0.88. What is the ratio of the % of GDP in Brazil in 2003 to that in 2005?
Offer a very short reply. 0.98. What is the ratio of the % of GDP of Eritrea in 2003 to that in 2005?
Make the answer very short. 1.3. What is the ratio of the % of GDP in Fragile and conflict affected situations in 2003 to that in 2006?
Make the answer very short. 1. What is the ratio of the % of GDP in Belgium in 2003 to that in 2006?
Your response must be concise. 0.87. What is the ratio of the % of GDP in Brazil in 2003 to that in 2006?
Make the answer very short. 0.95. What is the ratio of the % of GDP of Eritrea in 2003 to that in 2006?
Offer a very short reply. 1.94. What is the ratio of the % of GDP of Fragile and conflict affected situations in 2003 to that in 2007?
Offer a very short reply. 0.92. What is the ratio of the % of GDP of Belgium in 2003 to that in 2007?
Your answer should be very brief. 0.85. What is the ratio of the % of GDP in Brazil in 2003 to that in 2007?
Provide a succinct answer. 0.85. What is the ratio of the % of GDP in Eritrea in 2003 to that in 2007?
Your response must be concise. 2.09. What is the ratio of the % of GDP of Fragile and conflict affected situations in 2004 to that in 2005?
Your response must be concise. 0.93. What is the ratio of the % of GDP of Belgium in 2004 to that in 2005?
Offer a terse response. 0.95. What is the ratio of the % of GDP in Brazil in 2004 to that in 2005?
Your answer should be very brief. 1.03. What is the ratio of the % of GDP of Eritrea in 2004 to that in 2005?
Your answer should be compact. 1. What is the ratio of the % of GDP of Fragile and conflict affected situations in 2004 to that in 2006?
Your answer should be compact. 0.9. What is the ratio of the % of GDP in Belgium in 2004 to that in 2006?
Offer a terse response. 0.94. What is the ratio of the % of GDP of Brazil in 2004 to that in 2006?
Your answer should be compact. 1. What is the ratio of the % of GDP in Eritrea in 2004 to that in 2006?
Give a very brief answer. 1.48. What is the ratio of the % of GDP in Fragile and conflict affected situations in 2004 to that in 2007?
Offer a very short reply. 0.82. What is the ratio of the % of GDP in Belgium in 2004 to that in 2007?
Offer a very short reply. 0.92. What is the ratio of the % of GDP in Brazil in 2004 to that in 2007?
Your answer should be very brief. 0.9. What is the ratio of the % of GDP in Eritrea in 2004 to that in 2007?
Your answer should be very brief. 1.6. What is the ratio of the % of GDP in Fragile and conflict affected situations in 2005 to that in 2006?
Your answer should be compact. 0.96. What is the ratio of the % of GDP of Belgium in 2005 to that in 2006?
Make the answer very short. 0.99. What is the ratio of the % of GDP in Brazil in 2005 to that in 2006?
Give a very brief answer. 0.97. What is the ratio of the % of GDP of Eritrea in 2005 to that in 2006?
Keep it short and to the point. 1.49. What is the ratio of the % of GDP of Fragile and conflict affected situations in 2005 to that in 2007?
Provide a short and direct response. 0.88. What is the ratio of the % of GDP in Belgium in 2005 to that in 2007?
Provide a succinct answer. 0.97. What is the ratio of the % of GDP of Brazil in 2005 to that in 2007?
Your answer should be very brief. 0.87. What is the ratio of the % of GDP in Eritrea in 2005 to that in 2007?
Offer a terse response. 1.6. What is the ratio of the % of GDP of Fragile and conflict affected situations in 2006 to that in 2007?
Your response must be concise. 0.92. What is the ratio of the % of GDP in Belgium in 2006 to that in 2007?
Your answer should be compact. 0.98. What is the ratio of the % of GDP of Brazil in 2006 to that in 2007?
Make the answer very short. 0.9. What is the ratio of the % of GDP in Eritrea in 2006 to that in 2007?
Make the answer very short. 1.08. What is the difference between the highest and the second highest % of GDP of Fragile and conflict affected situations?
Offer a very short reply. 1.02. What is the difference between the highest and the second highest % of GDP of Belgium?
Keep it short and to the point. 0.56. What is the difference between the highest and the second highest % of GDP of Brazil?
Make the answer very short. 0.87. What is the difference between the highest and the second highest % of GDP in Eritrea?
Your answer should be very brief. 5.71. What is the difference between the highest and the lowest % of GDP in Fragile and conflict affected situations?
Give a very brief answer. 4.09. What is the difference between the highest and the lowest % of GDP in Belgium?
Ensure brevity in your answer.  3.78. What is the difference between the highest and the lowest % of GDP in Brazil?
Give a very brief answer. 2.93. What is the difference between the highest and the lowest % of GDP in Eritrea?
Provide a short and direct response. 22.59. 